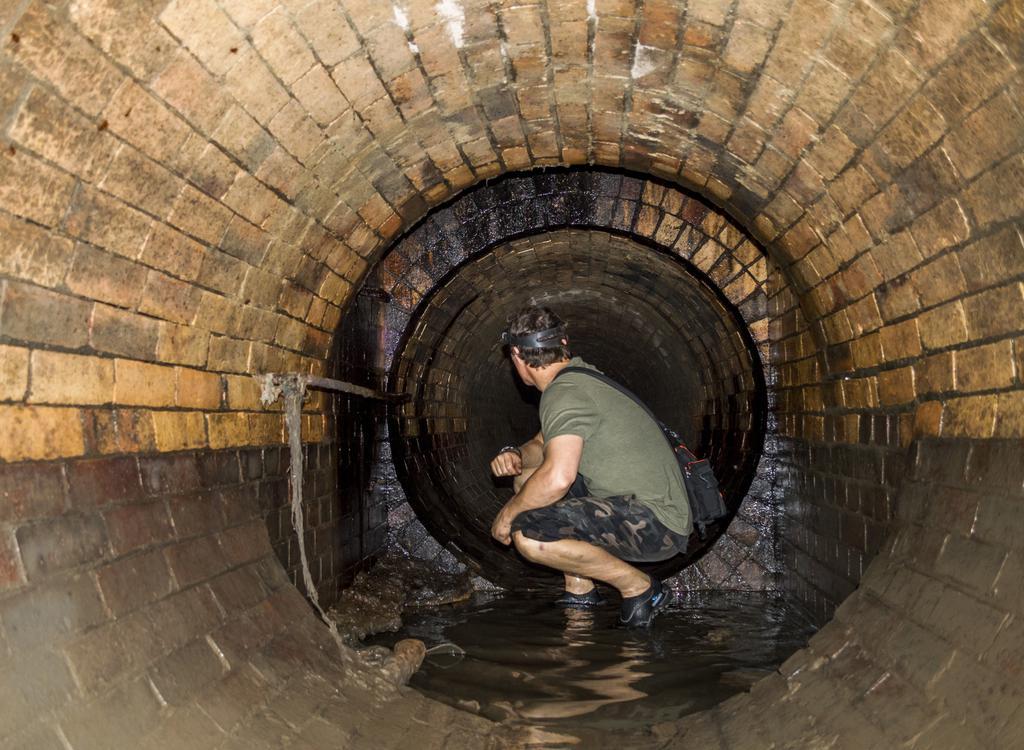Describe this image in one or two sentences. As we can see in the image there is a man wearing green color dress and sitting. There is tunnel and water. 